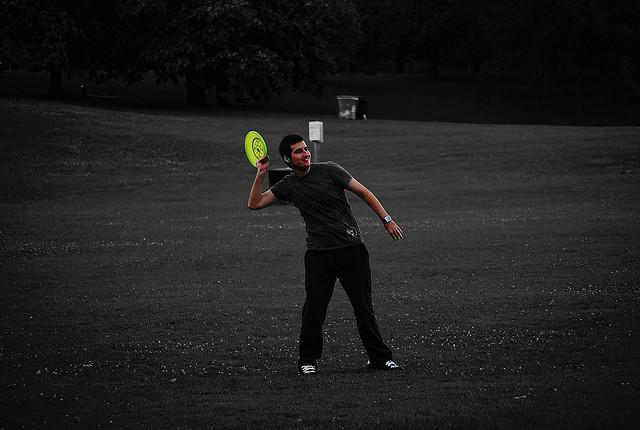Is there water?
Keep it brief. No. Are those street lights in the background?
Answer briefly. No. Are these two in danger of hitting pedestrians with the frisbee?
Write a very short answer. No. Is he right handed?
Give a very brief answer. Yes. What color is the Frisbee?
Give a very brief answer. Yellow. What object sticks out?
Concise answer only. Frisbee. What sport is this guy doing?
Answer briefly. Frisbee. Is he leaving a wake?
Give a very brief answer. No. Is this a woman or a man?
Answer briefly. Man. What is the man doing?
Give a very brief answer. Frisbee. Which sport is this?
Quick response, please. Frisbee. What sport is depicted?
Give a very brief answer. Frisbee. Where are the man's arms?
Be succinct. In air and by his side. What is the man throwing?
Be succinct. Frisbee. What is the person doing?
Write a very short answer. Frisbee. What game is being played in this picture?
Be succinct. Frisbee. What kind of sneakers are those?
Write a very short answer. White. What is the boy standing on?
Write a very short answer. Grass. What is this person wearing on their chest?
Concise answer only. Shirt. Is the guy jumping?
Quick response, please. No. What color is his shirt?
Quick response, please. Black. Are they wearing shorts?
Give a very brief answer. No. What kind of shoes is the man in black wearing?
Write a very short answer. Tennis shoes. 